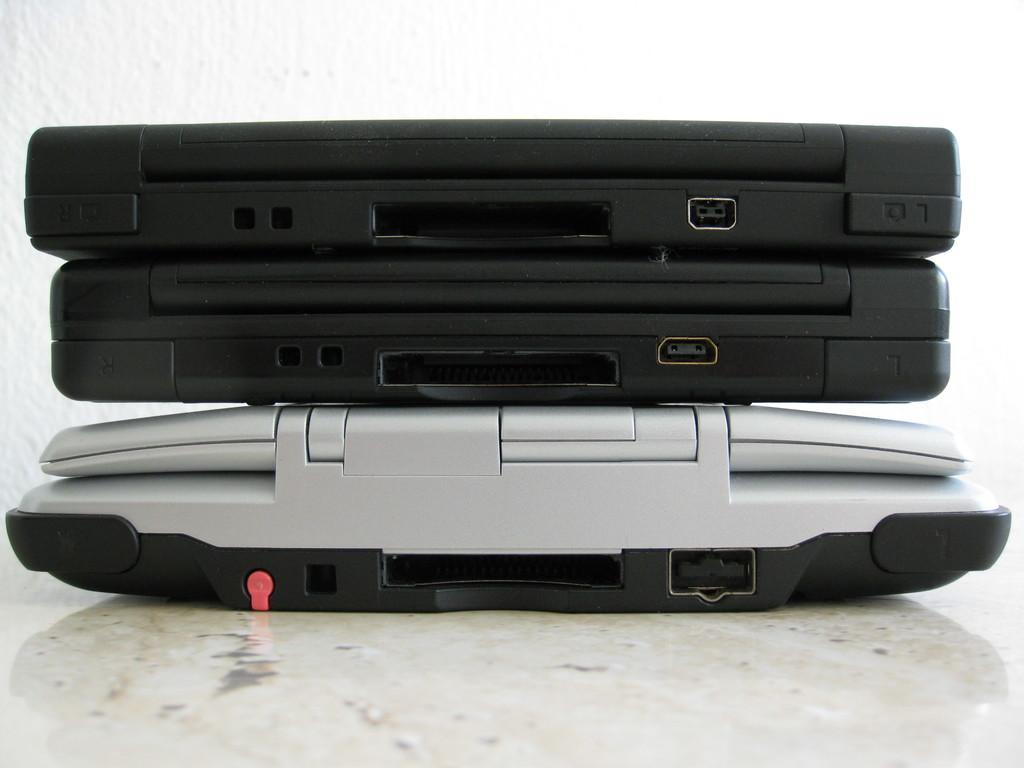How many laptops are visible in the image? There are three laptops in the image. Where are the laptops located? The laptops are placed on the floor. What can be seen in the background of the image? There is a wall in the background of the image. How many toes can be seen on the laptops in the image? There are no toes visible on the laptops in the image, as laptops do not have toes. 